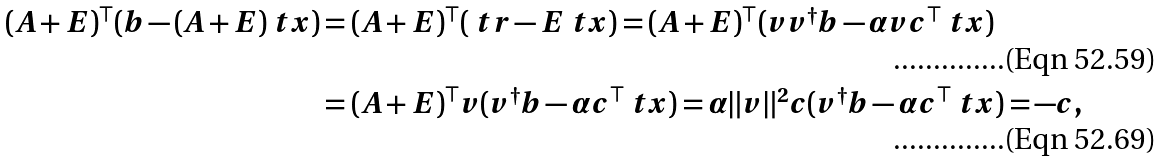Convert formula to latex. <formula><loc_0><loc_0><loc_500><loc_500>( A + E ) ^ { \top } ( b - ( A + E ) \ t x ) & = ( A + E ) ^ { \top } ( \ t r - E \ t x ) = ( A + E ) ^ { \top } ( v v ^ { \dagger } b - \alpha v c ^ { \top } \ t x ) \\ & = ( A + E ) ^ { \top } v ( v ^ { \dagger } b - \alpha c ^ { \top } \ t x ) = \alpha \| v \| ^ { 2 } c ( v ^ { \dagger } b - \alpha c ^ { \top } \ t x ) = - c ,</formula> 